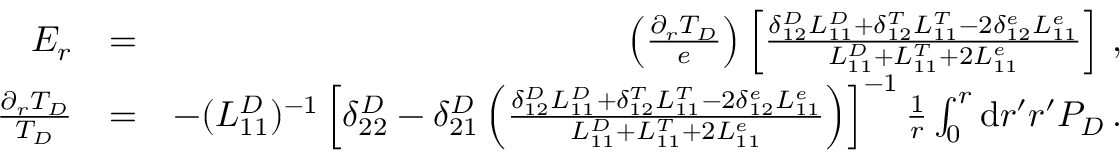Convert formula to latex. <formula><loc_0><loc_0><loc_500><loc_500>\begin{array} { r l r } { E _ { r } } & { = } & { \left ( \frac { \partial _ { r } T _ { D } } { e } \right ) \left [ \frac { \delta _ { 1 2 } ^ { D } L _ { 1 1 } ^ { D } + \delta _ { 1 2 } ^ { T } L _ { 1 1 } ^ { T } - 2 \delta _ { 1 2 } ^ { e } L _ { 1 1 } ^ { e } } { L _ { 1 1 } ^ { D } + L _ { 1 1 } ^ { T } + 2 L _ { 1 1 } ^ { e } } \right ] \, , } \\ { \frac { \partial _ { r } T _ { D } } { T _ { D } } } & { = } & { - ( L _ { 1 1 } ^ { D } ) ^ { - 1 } \left [ \delta _ { 2 2 } ^ { D } - \delta _ { 2 1 } ^ { D } \left ( \frac { \delta _ { 1 2 } ^ { D } L _ { 1 1 } ^ { D } + \delta _ { 1 2 } ^ { T } L _ { 1 1 } ^ { T } - 2 \delta _ { 1 2 } ^ { e } L _ { 1 1 } ^ { e } } { L _ { 1 1 } ^ { D } + L _ { 1 1 } ^ { T } + 2 L _ { 1 1 } ^ { e } } \right ) \right ] ^ { - 1 } \frac { 1 } { r } \int _ { 0 } ^ { r } d r ^ { \prime } r ^ { \prime } P _ { D } \, . } \end{array}</formula> 